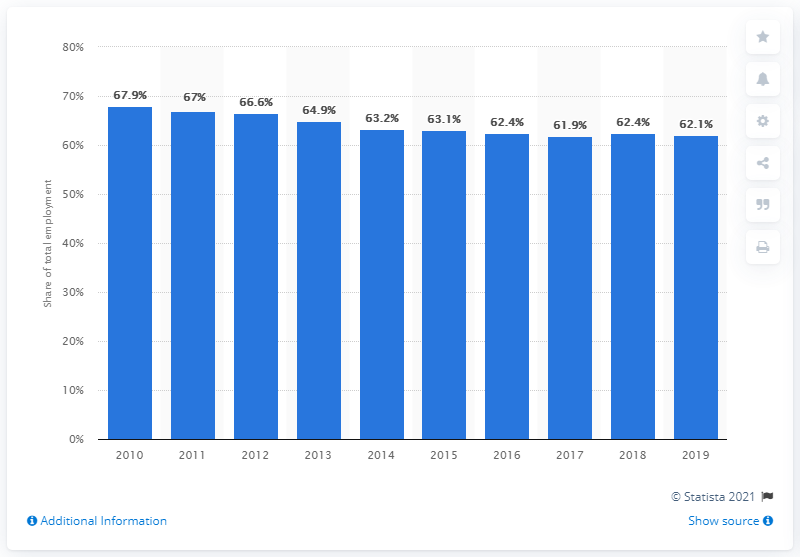Specify some key components in this picture. In 2019, the percentage of informal employment in Colombia was 62.1%. 